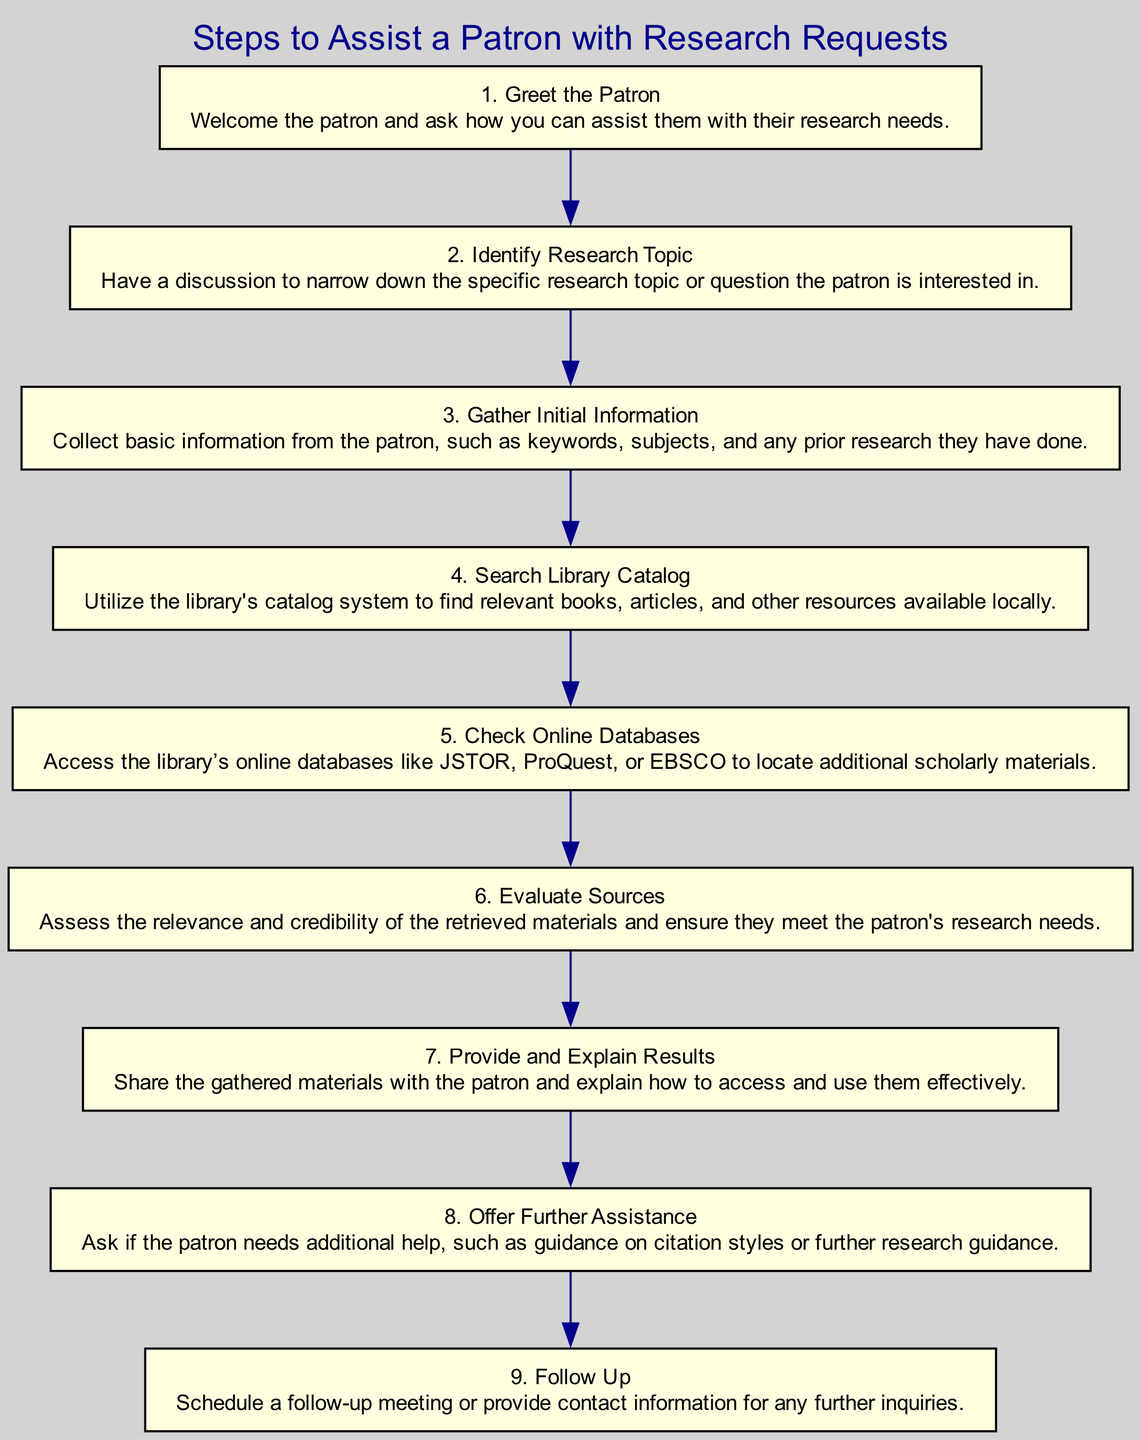What is the first step in assisting a patron? The first step listed in the diagram is "Greet the Patron". It is identified as step 1, which focuses on welcoming the patron.
Answer: Greet the Patron How many total steps are there in the diagram? By counting the steps listed from 1 to 9, it is evident that there are 9 distinct steps mentioned.
Answer: 9 What is the description of step 5? Step 5 is "Check Online Databases", which allows access to various scholarly materials through the library’s databases. The description explicitly provides details about this action.
Answer: Access the library’s online databases like JSTOR, ProQuest, or EBSCO to locate additional scholarly materials What is the relationship between "Evaluate Sources" and "Provide and Explain Results"? "Evaluate Sources" is step 6 and occurs before "Provide and Explain Results", which is step 7. The patron must first evaluate the sources to ensure they meet their needs before the results can be provided.
Answer: Evaluate Sources → Provide and Explain Results If you skip step 3, which step follows? If step 3 "Gather Initial Information" is skipped, the next step would be step 4 "Search Library Catalog". This demonstrates a logical flow of steps, but skipping step 3 may impact the effectiveness of the search.
Answer: Search Library Catalog What assistance is offered after "Provide and Explain Results"? After sharing and explaining the results, the next step is "Offer Further Assistance". This indicates that follow-up support is available to the patron regarding their research needs.
Answer: Offer Further Assistance Which step involves assessing materials for relevance? The step that specifically involves assessing the materials for relevance and credibility is "Evaluate Sources", which is step 6. It focuses on ensuring the materials meet the patron's needs.
Answer: Evaluate Sources What is the final step in the diagram? The final step is "Follow Up", which is step 9. This indicates the importance of securing ongoing communication for any further inquiries from the patron.
Answer: Follow Up What step comes after "Identify Research Topic"? The step that follows "Identify Research Topic", which is step 2, is "Gather Initial Information", which is step 3. This progression highlights the structured approach to assisting patrons.
Answer: Gather Initial Information 